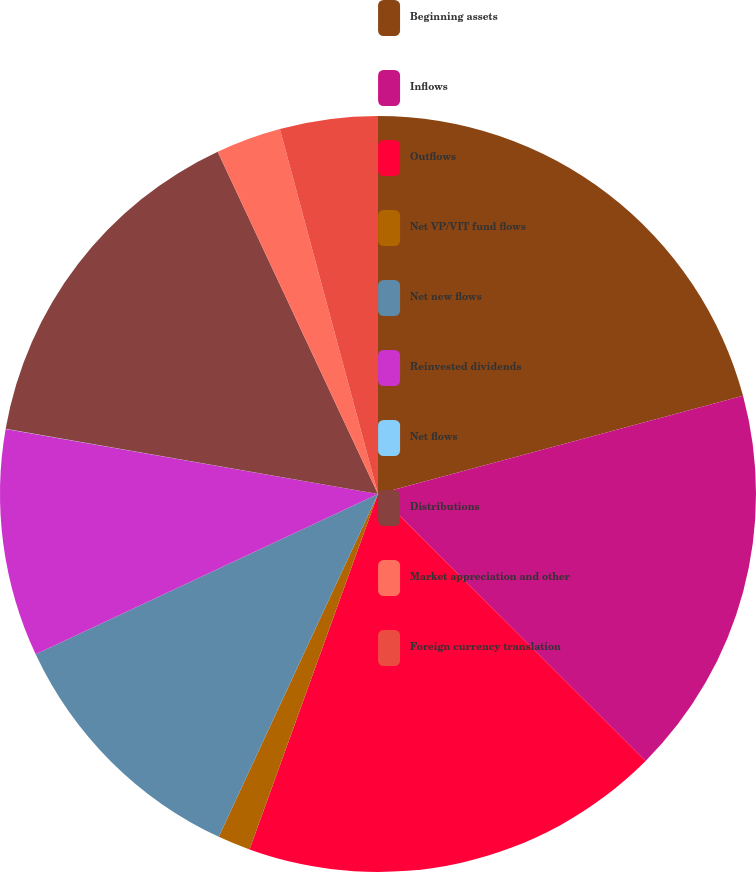Convert chart. <chart><loc_0><loc_0><loc_500><loc_500><pie_chart><fcel>Beginning assets<fcel>Inflows<fcel>Outflows<fcel>Net VP/VIT fund flows<fcel>Net new flows<fcel>Reinvested dividends<fcel>Net flows<fcel>Distributions<fcel>Market appreciation and other<fcel>Foreign currency translation<nl><fcel>20.82%<fcel>16.66%<fcel>18.04%<fcel>1.4%<fcel>11.11%<fcel>9.72%<fcel>0.01%<fcel>15.27%<fcel>2.79%<fcel>4.18%<nl></chart> 